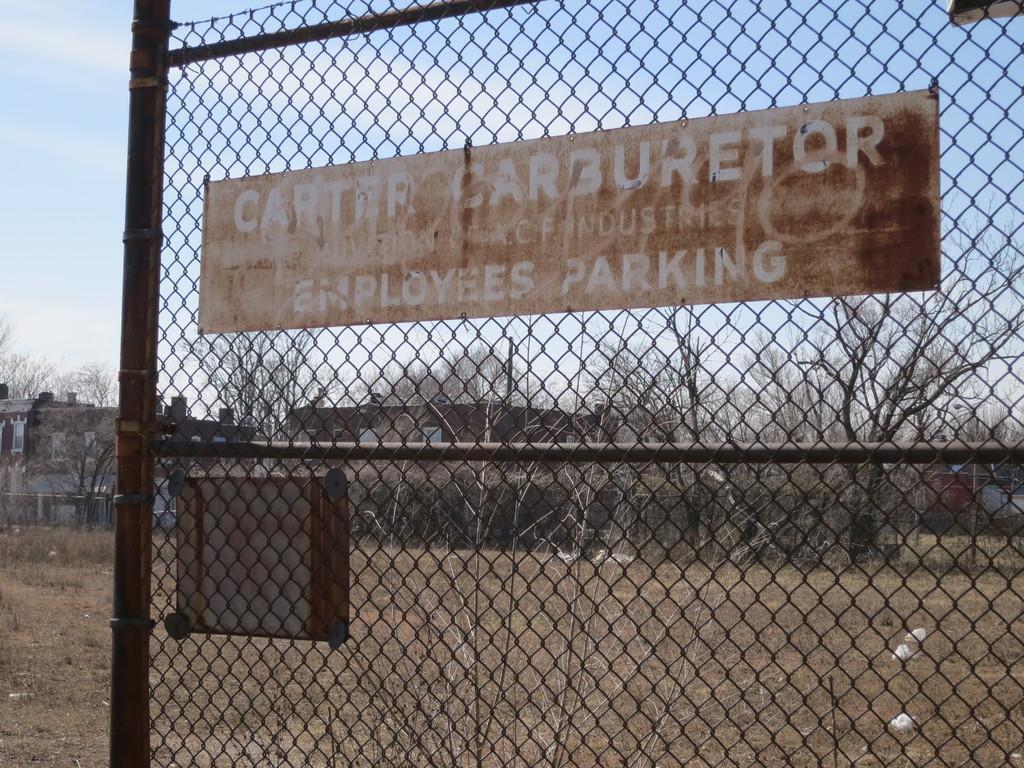Describe this image in one or two sentences. In this picture we can see a fence with the board. Behind the fence there are trees, buildings and a sky. 